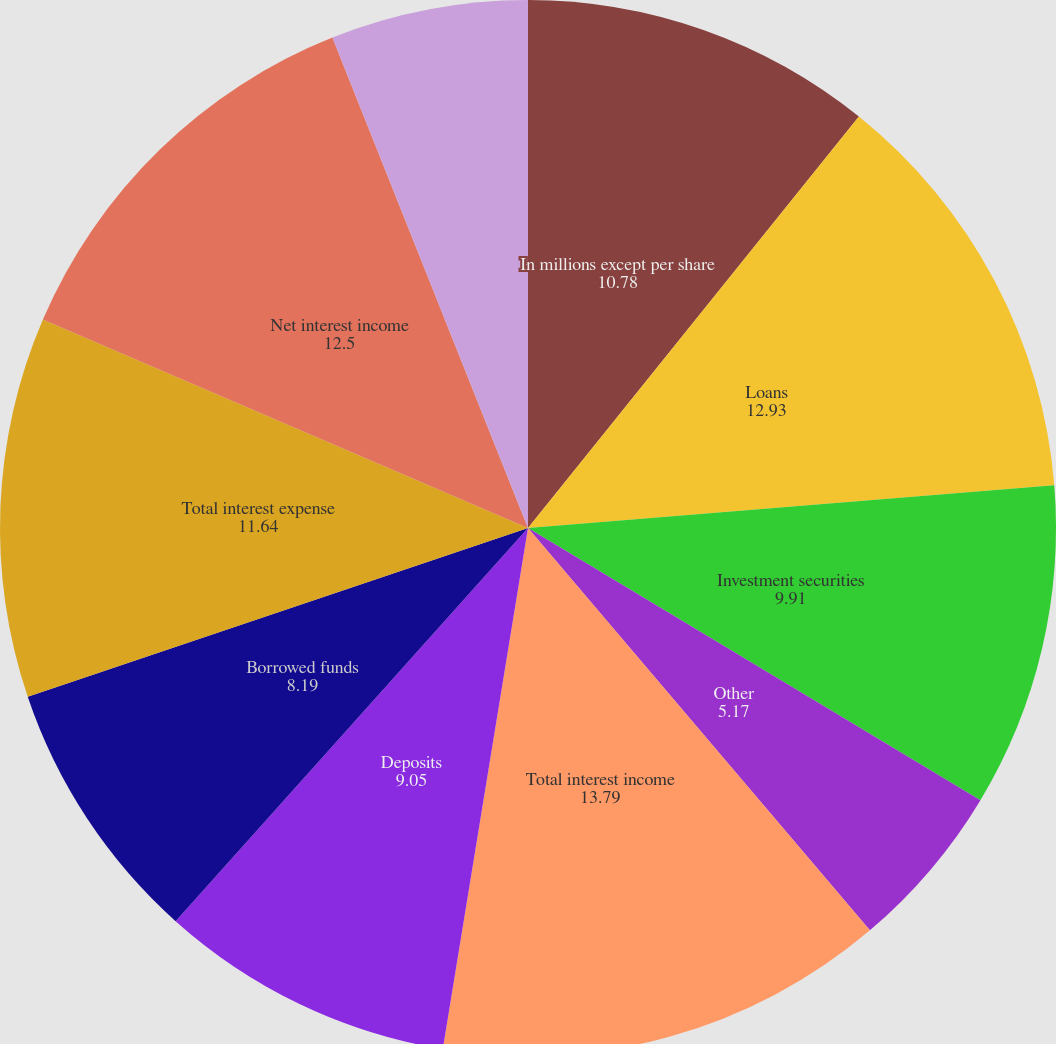Convert chart. <chart><loc_0><loc_0><loc_500><loc_500><pie_chart><fcel>In millions except per share<fcel>Loans<fcel>Investment securities<fcel>Other<fcel>Total interest income<fcel>Deposits<fcel>Borrowed funds<fcel>Total interest expense<fcel>Net interest income<fcel>Asset management<nl><fcel>10.78%<fcel>12.93%<fcel>9.91%<fcel>5.17%<fcel>13.79%<fcel>9.05%<fcel>8.19%<fcel>11.64%<fcel>12.5%<fcel>6.04%<nl></chart> 